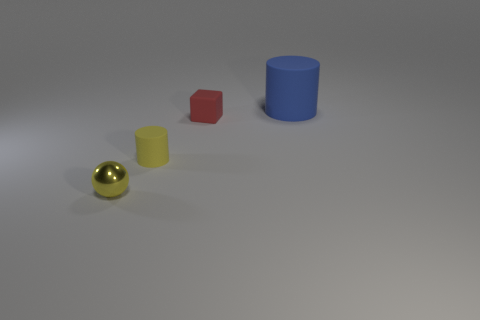Add 2 tiny brown matte spheres. How many objects exist? 6 Subtract all balls. How many objects are left? 3 Subtract 1 red blocks. How many objects are left? 3 Subtract all shiny spheres. Subtract all tiny balls. How many objects are left? 2 Add 3 red matte things. How many red matte things are left? 4 Add 4 small red matte objects. How many small red matte objects exist? 5 